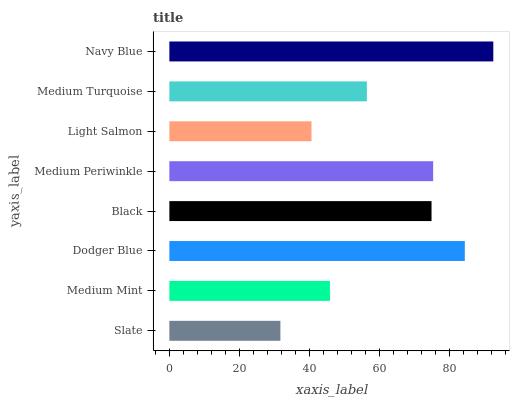Is Slate the minimum?
Answer yes or no. Yes. Is Navy Blue the maximum?
Answer yes or no. Yes. Is Medium Mint the minimum?
Answer yes or no. No. Is Medium Mint the maximum?
Answer yes or no. No. Is Medium Mint greater than Slate?
Answer yes or no. Yes. Is Slate less than Medium Mint?
Answer yes or no. Yes. Is Slate greater than Medium Mint?
Answer yes or no. No. Is Medium Mint less than Slate?
Answer yes or no. No. Is Black the high median?
Answer yes or no. Yes. Is Medium Turquoise the low median?
Answer yes or no. Yes. Is Medium Mint the high median?
Answer yes or no. No. Is Navy Blue the low median?
Answer yes or no. No. 